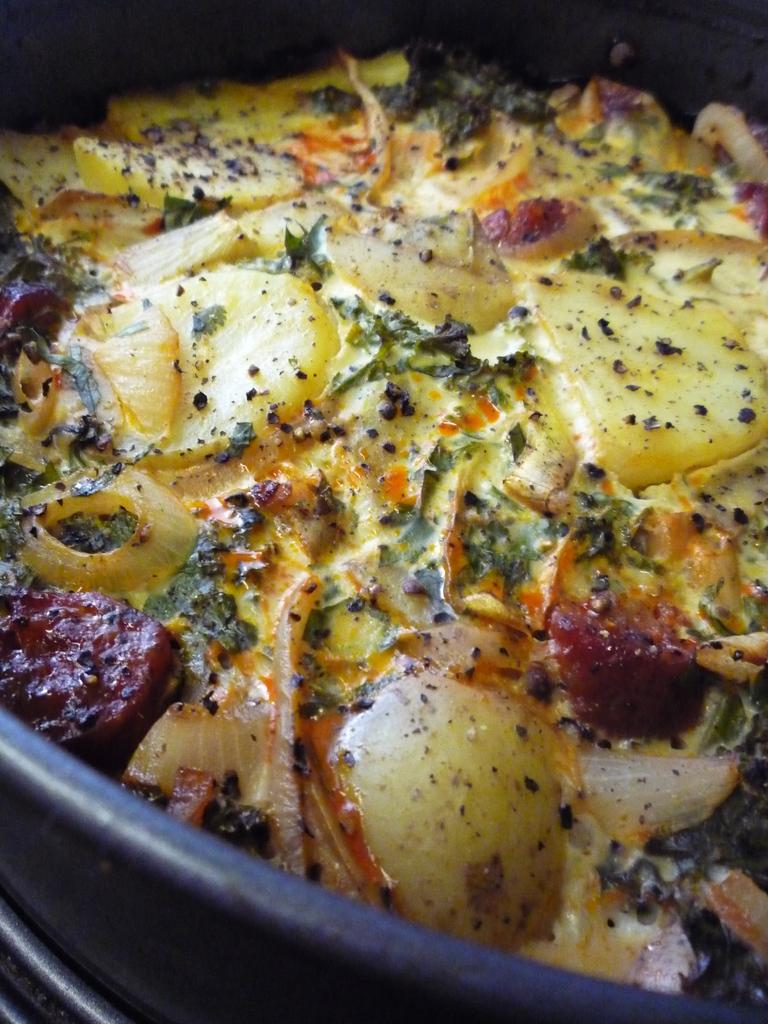What is the focus of the image? The image is a close view. What object can be seen in the image? There is a black color pan in the image. What is inside the pan? Food items are kept in the pan. Where is the machine placed in the image? There is no machine present in the image. What type of discussion is taking place in the image? There is no discussion taking place in the image; it only shows a black color pan with food items. 